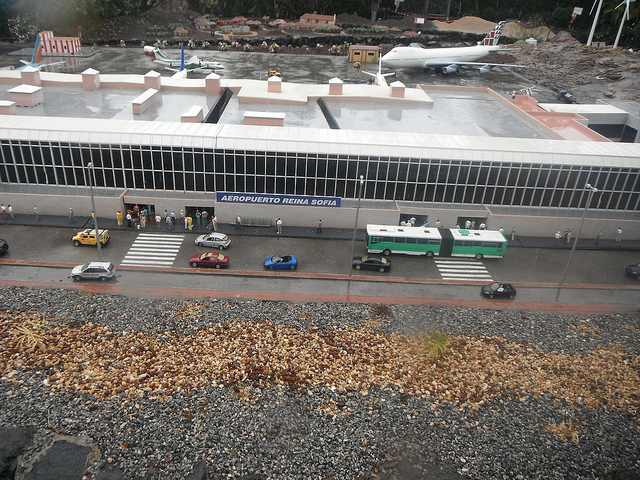Extract all visible text content from this image. AEROPUERTO REINA SOFIA 